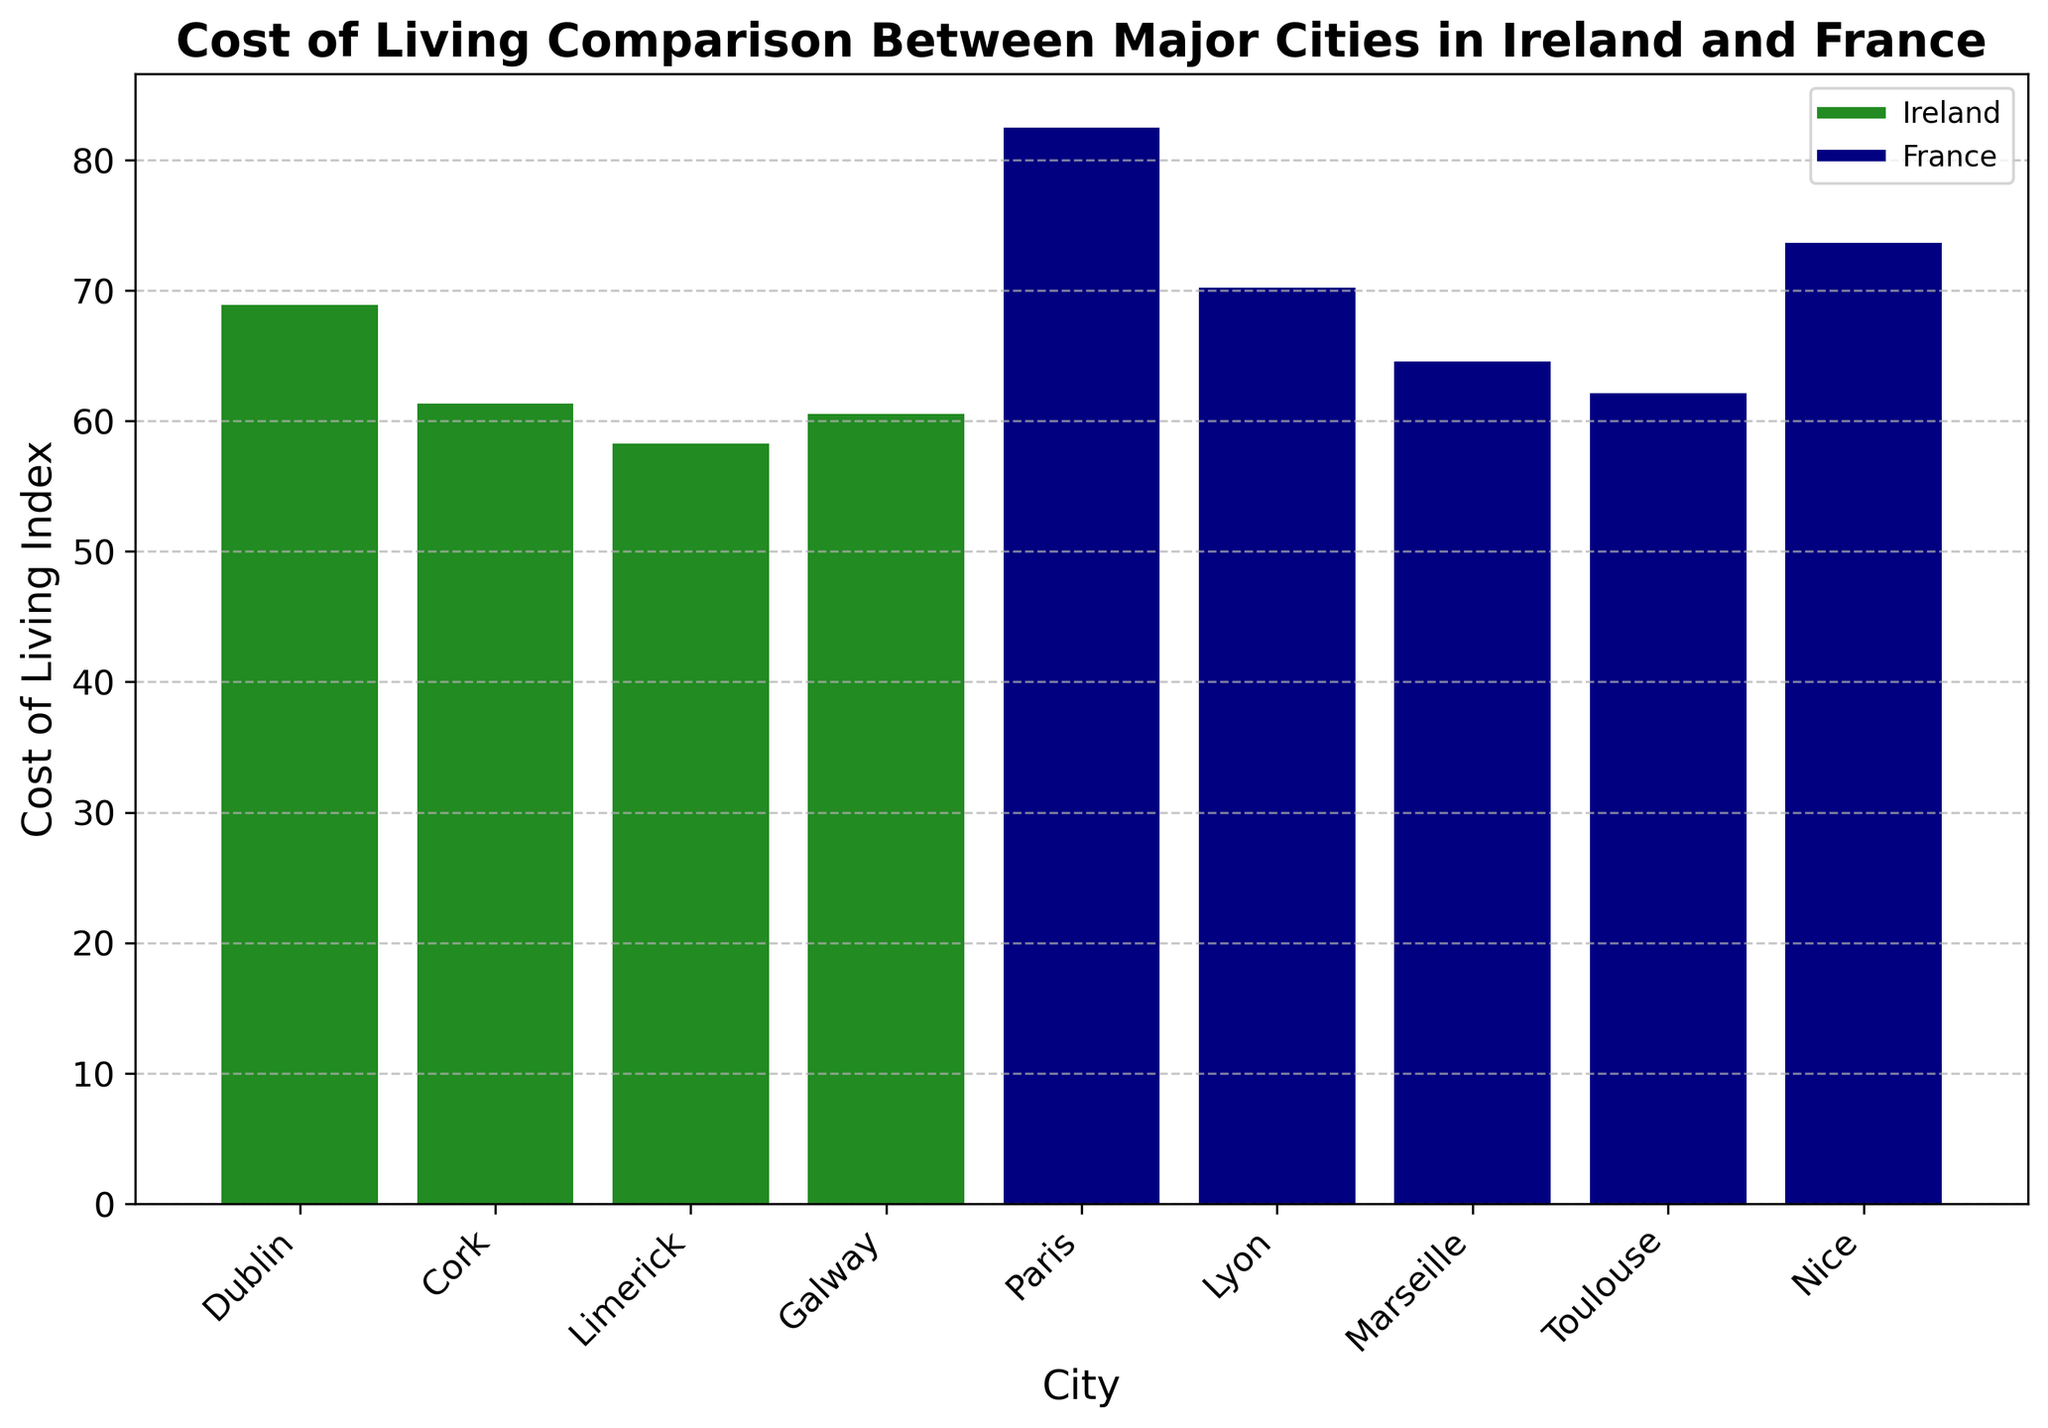Which city has the highest Cost of Living Index? Observe the highest bar in the figure, which corresponds to Paris.
Answer: Paris What's the difference in the Cost of Living Index between Dublin and Galway? Look at the heights of the bars for Dublin and Galway. Dublin is 68.89, Galway is 60.54. The difference is 68.89 - 60.54.
Answer: 8.35 Compare the Cost of Living Index of Cork and Marseille. Which one is higher? Observe the heights of the bars for Cork and Marseille. Cork is 61.32, Marseille is 64.57. Marseille is higher.
Answer: Marseille What's the average Cost of Living Index for the French cities? Find the Cost of Living Index for all French cities (Paris, Lyon, Marseille, Toulouse, Nice) and calculate the average. (82.50 + 70.23 + 64.57 + 62.15 + 73.64) / 5 = 70.218.
Answer: 70.22 Which city has the lowest Cost of Living Index, and what is its value? Observe the lowest bar in the figure, which corresponds to Limerick, with a value of 58.27.
Answer: Limerick Compare the Cost of Living Index between Toulouse and the average of all Irish cities. Which one is higher? Calculate the average for Irish cities (Dublin, Cork, Limerick, Galway). (68.89 + 61.32 + 58.27 + 60.54) / 4 = 62.255. Toulouse is 62.15. Compare the two values.
Answer: average of Irish cities What is the median Cost of Living Index for all the cities listed? Arrange the Cost of Living Index values in ascending order: 58.27, 60.54, 61.32, 62.15, 64.57, 68.89, 70.23, 73.64, 82.50. The median value is the middle value when the data is ordered, which is 64.57.
Answer: 64.57 Among the French cities, which city has the closest Cost of Living Index to the Irish city average? Calculate the average for Irish cities, 62.255. Compare this to the values for French cities: Paris 82.50, Lyon 70.23, Marseille 64.57, Toulouse 62.15, Nice 73.64. Toulouse (62.15) is the closest.
Answer: Toulouse 